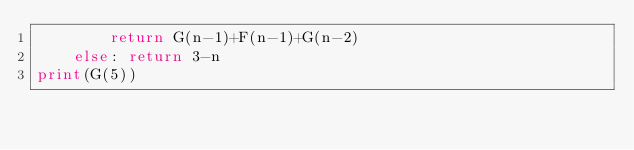Convert code to text. <code><loc_0><loc_0><loc_500><loc_500><_Python_>        return G(n-1)+F(n-1)+G(n-2)
    else: return 3-n
print(G(5))</code> 